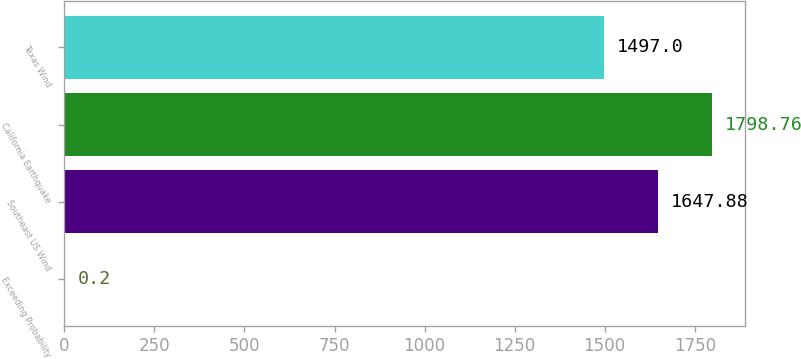Convert chart to OTSL. <chart><loc_0><loc_0><loc_500><loc_500><bar_chart><fcel>Exceeding Probability<fcel>Southeast US Wind<fcel>California Earthquake<fcel>Texas Wind<nl><fcel>0.2<fcel>1647.88<fcel>1798.76<fcel>1497<nl></chart> 